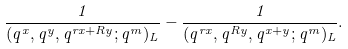<formula> <loc_0><loc_0><loc_500><loc_500>\frac { 1 } { ( q ^ { x } , q ^ { y } , q ^ { r x + R y } ; q ^ { m } ) _ { L } } - \frac { 1 } { ( q ^ { r x } , q ^ { R y } , q ^ { x + y } ; q ^ { m } ) _ { L } } .</formula> 